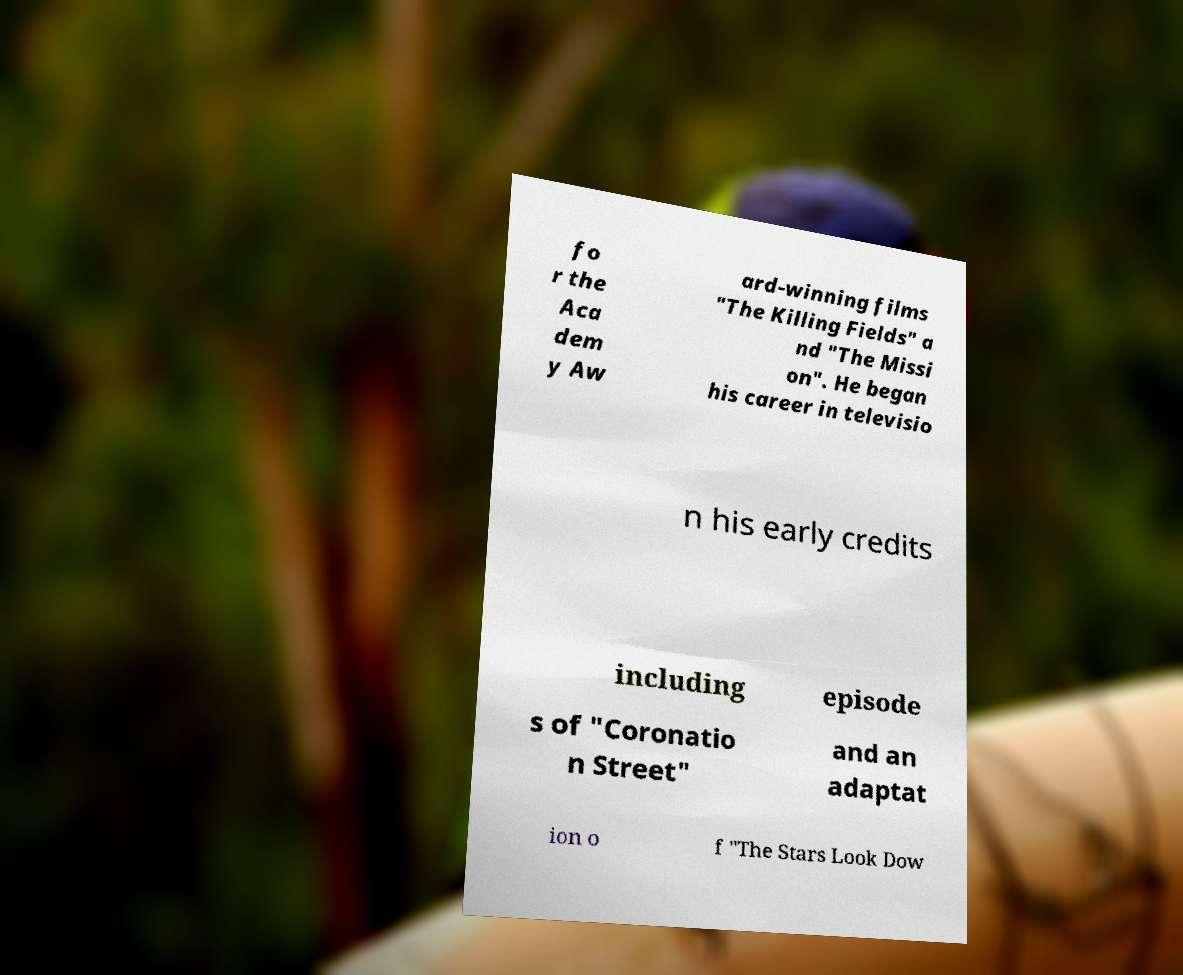I need the written content from this picture converted into text. Can you do that? fo r the Aca dem y Aw ard-winning films "The Killing Fields" a nd "The Missi on". He began his career in televisio n his early credits including episode s of "Coronatio n Street" and an adaptat ion o f "The Stars Look Dow 